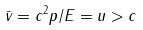<formula> <loc_0><loc_0><loc_500><loc_500>\bar { v } = c ^ { 2 } p / E = u > c</formula> 